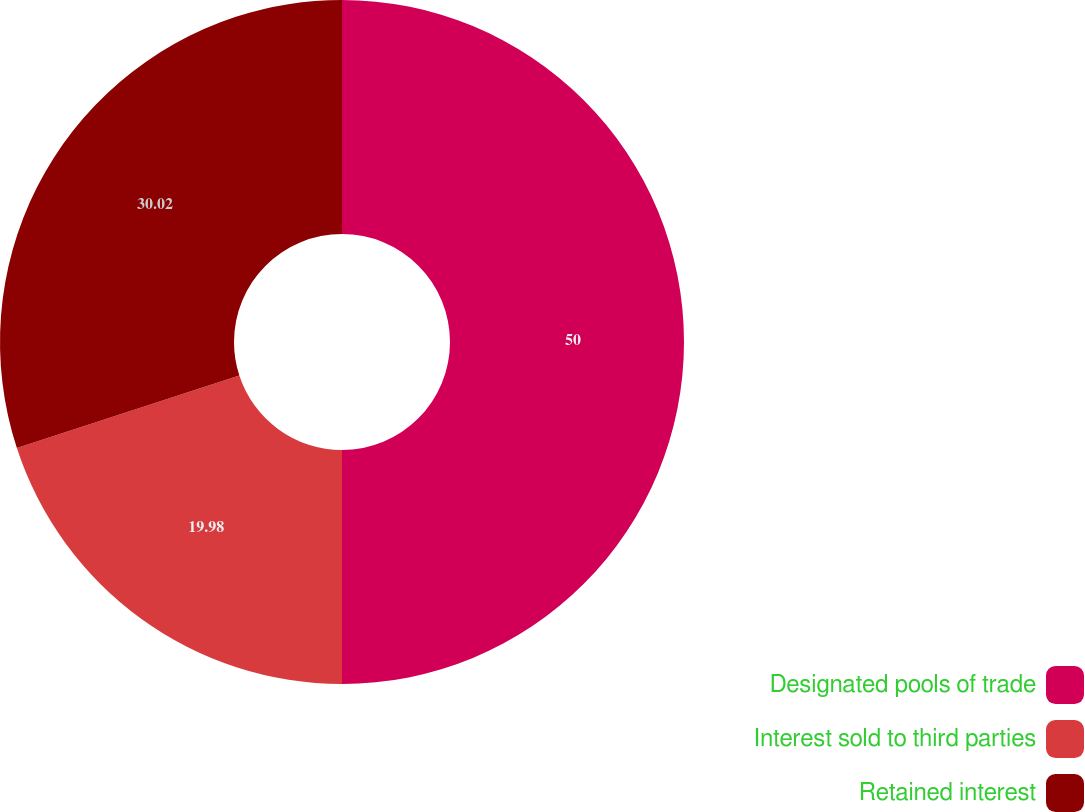Convert chart to OTSL. <chart><loc_0><loc_0><loc_500><loc_500><pie_chart><fcel>Designated pools of trade<fcel>Interest sold to third parties<fcel>Retained interest<nl><fcel>50.0%<fcel>19.98%<fcel>30.02%<nl></chart> 